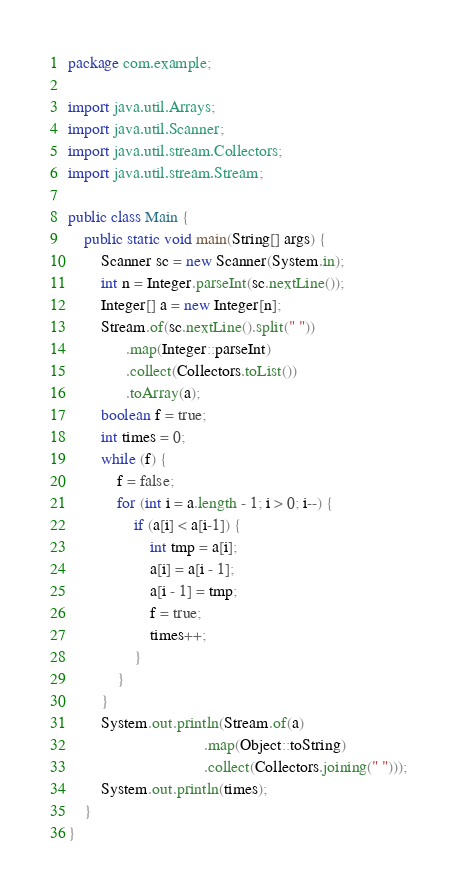Convert code to text. <code><loc_0><loc_0><loc_500><loc_500><_Java_>package com.example;

import java.util.Arrays;
import java.util.Scanner;
import java.util.stream.Collectors;
import java.util.stream.Stream;

public class Main {
    public static void main(String[] args) {
        Scanner sc = new Scanner(System.in);
        int n = Integer.parseInt(sc.nextLine());
        Integer[] a = new Integer[n];
        Stream.of(sc.nextLine().split(" "))
              .map(Integer::parseInt)
              .collect(Collectors.toList())
              .toArray(a);
        boolean f = true;
        int times = 0;
        while (f) {
            f = false;
            for (int i = a.length - 1; i > 0; i--) {
                if (a[i] < a[i-1]) {
                    int tmp = a[i];
                    a[i] = a[i - 1];
                    a[i - 1] = tmp;
                    f = true;
                    times++;
                }
            }
        }
        System.out.println(Stream.of(a)
                                 .map(Object::toString)
                                 .collect(Collectors.joining(" ")));
        System.out.println(times);
    }
}

</code> 